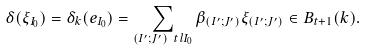<formula> <loc_0><loc_0><loc_500><loc_500>\delta ( \xi _ { I _ { 0 } } ) = \delta _ { k } ( e _ { I _ { 0 } } ) = \sum _ { ( I ^ { \prime } ; J ^ { \prime } ) \ t l I _ { 0 } } \beta _ { ( I ^ { \prime } ; J ^ { \prime } ) } \xi _ { ( I ^ { \prime } ; J ^ { \prime } ) } \in B _ { t + 1 } ( k ) .</formula> 